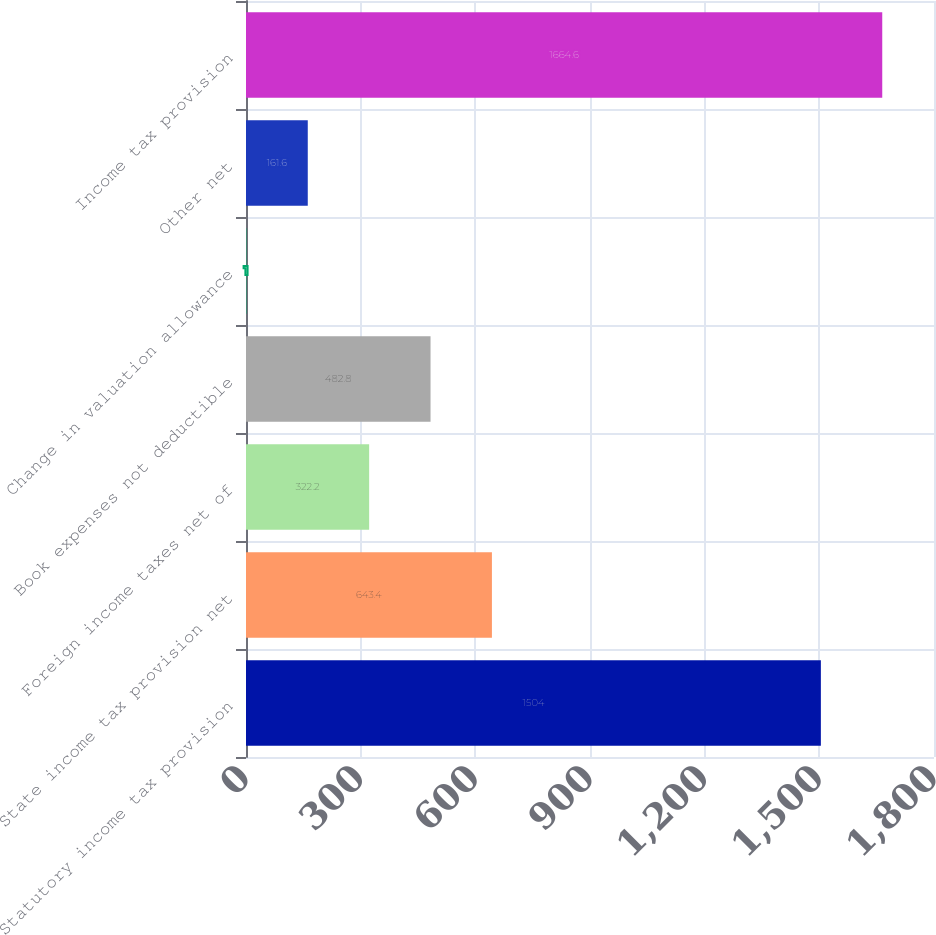Convert chart. <chart><loc_0><loc_0><loc_500><loc_500><bar_chart><fcel>Statutory income tax provision<fcel>State income tax provision net<fcel>Foreign income taxes net of<fcel>Book expenses not deductible<fcel>Change in valuation allowance<fcel>Other net<fcel>Income tax provision<nl><fcel>1504<fcel>643.4<fcel>322.2<fcel>482.8<fcel>1<fcel>161.6<fcel>1664.6<nl></chart> 